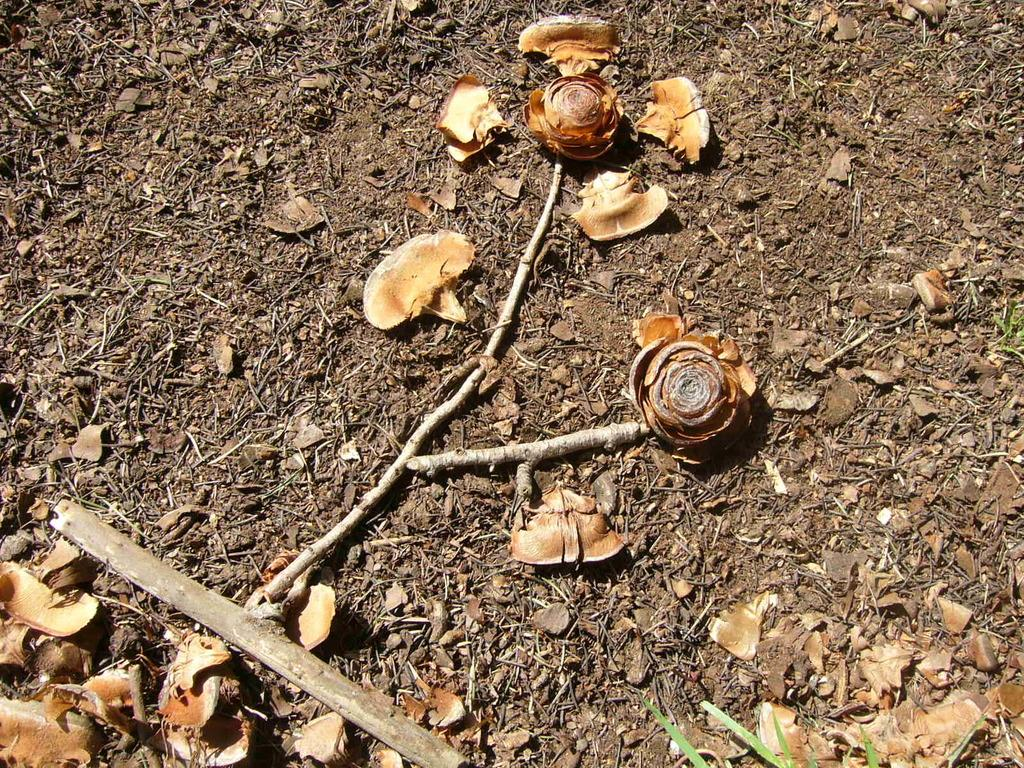What type of natural objects can be seen in the image? There are shells, dried leaves, and stems in the image. What is the surface on which the objects are placed? The objects are placed on dried land. How many beds can be seen in the image? There are no beds present in the image. What type of stick is being used to stir the dried leaves in the image? There is no stick or stirring action depicted in the image; the dried leaves are simply lying on the dried land. 